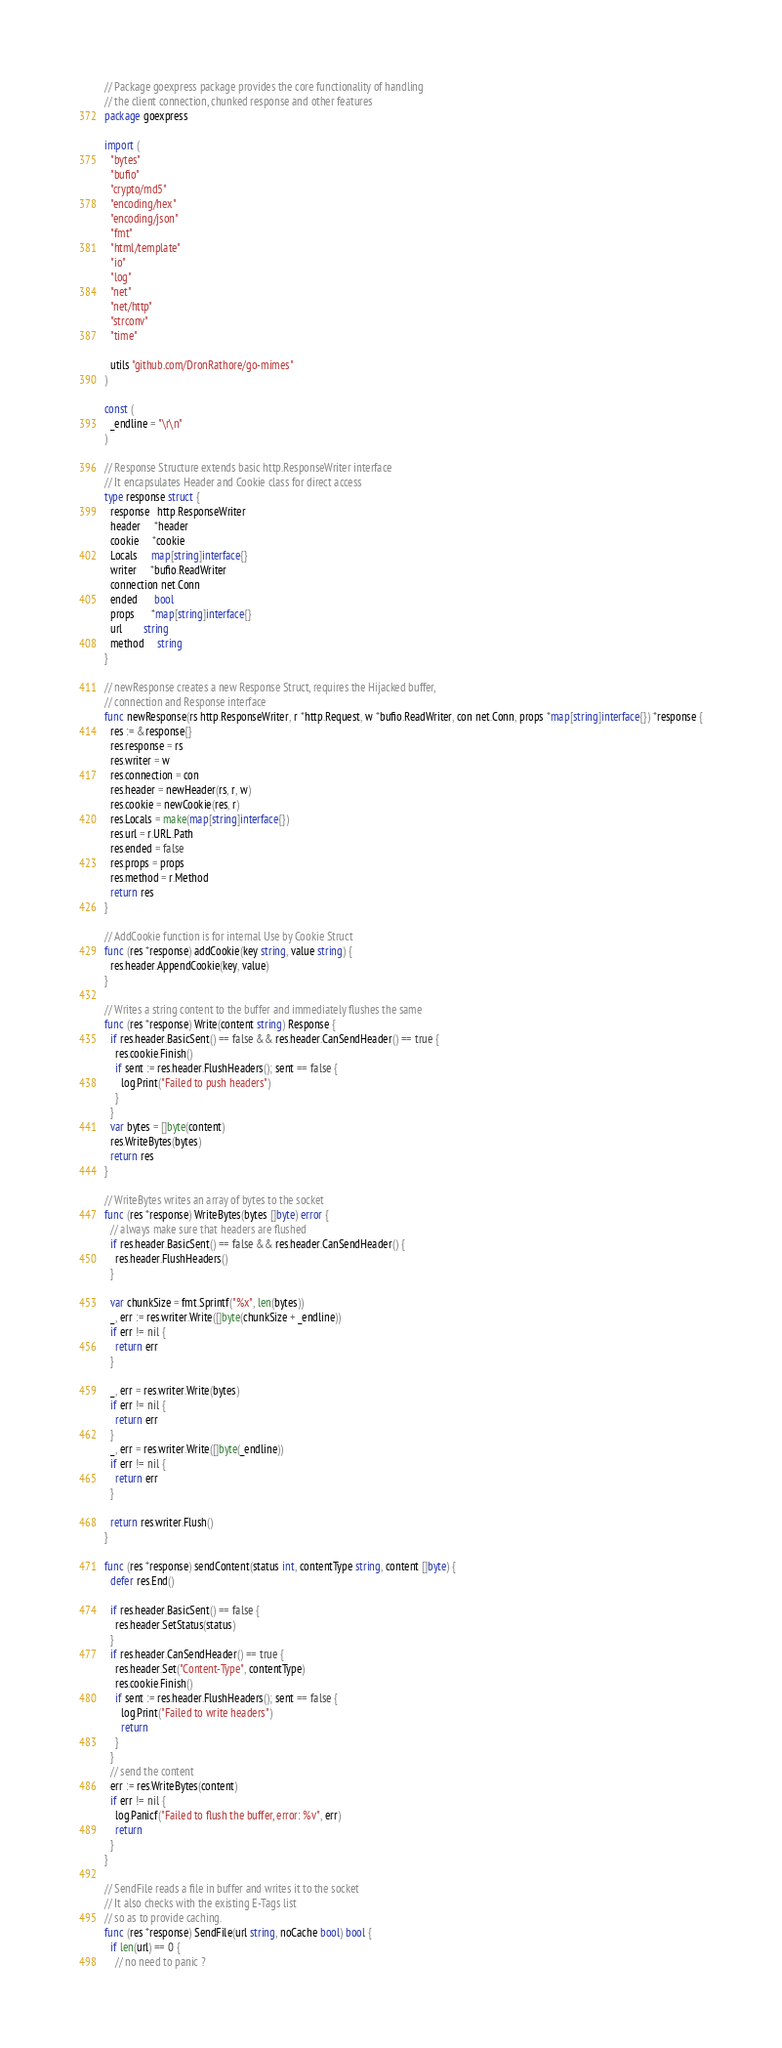Convert code to text. <code><loc_0><loc_0><loc_500><loc_500><_Go_>// Package goexpress package provides the core functionality of handling
// the client connection, chunked response and other features
package goexpress

import (
  "bytes"
  "bufio"
  "crypto/md5"
  "encoding/hex"
  "encoding/json"
  "fmt"
  "html/template"
  "io"
  "log"
  "net"
  "net/http"
  "strconv"
  "time"

  utils "github.com/DronRathore/go-mimes"
)

const (
  _endline = "\r\n"
)

// Response Structure extends basic http.ResponseWriter interface
// It encapsulates Header and Cookie class for direct access
type response struct {
  response   http.ResponseWriter
  header     *header
  cookie     *cookie
  Locals     map[string]interface{}
  writer     *bufio.ReadWriter
  connection net.Conn
  ended      bool
  props      *map[string]interface{}
  url        string
  method     string
}

// newResponse creates a new Response Struct, requires the Hijacked buffer,
// connection and Response interface
func newResponse(rs http.ResponseWriter, r *http.Request, w *bufio.ReadWriter, con net.Conn, props *map[string]interface{}) *response {
  res := &response{}
  res.response = rs
  res.writer = w
  res.connection = con
  res.header = newHeader(rs, r, w)
  res.cookie = newCookie(res, r)
  res.Locals = make(map[string]interface{})
  res.url = r.URL.Path
  res.ended = false
  res.props = props
  res.method = r.Method
  return res
}

// AddCookie function is for internal Use by Cookie Struct
func (res *response) addCookie(key string, value string) {
  res.header.AppendCookie(key, value)
}

// Writes a string content to the buffer and immediately flushes the same
func (res *response) Write(content string) Response {
  if res.header.BasicSent() == false && res.header.CanSendHeader() == true {
    res.cookie.Finish()
    if sent := res.header.FlushHeaders(); sent == false {
      log.Print("Failed to push headers")
    }
  }
  var bytes = []byte(content)
  res.WriteBytes(bytes)
  return res
}

// WriteBytes writes an array of bytes to the socket
func (res *response) WriteBytes(bytes []byte) error {
  // always make sure that headers are flushed
  if res.header.BasicSent() == false && res.header.CanSendHeader() {
    res.header.FlushHeaders()
  }

  var chunkSize = fmt.Sprintf("%x", len(bytes))
  _, err := res.writer.Write([]byte(chunkSize + _endline))
  if err != nil {
    return err
  }

  _, err = res.writer.Write(bytes)
  if err != nil {
    return err
  }
  _, err = res.writer.Write([]byte(_endline))
  if err != nil {
    return err
  }

  return res.writer.Flush()
}

func (res *response) sendContent(status int, contentType string, content []byte) {
  defer res.End()

  if res.header.BasicSent() == false {
    res.header.SetStatus(status)
  }
  if res.header.CanSendHeader() == true {
    res.header.Set("Content-Type", contentType)
    res.cookie.Finish()
    if sent := res.header.FlushHeaders(); sent == false {
      log.Print("Failed to write headers")
      return
    }
  }
  // send the content
  err := res.WriteBytes(content)
  if err != nil {
    log.Panicf("Failed to flush the buffer, error: %v", err)
    return
  }
}

// SendFile reads a file in buffer and writes it to the socket
// It also checks with the existing E-Tags list
// so as to provide caching.
func (res *response) SendFile(url string, noCache bool) bool {
  if len(url) == 0 {
    // no need to panic ?</code> 